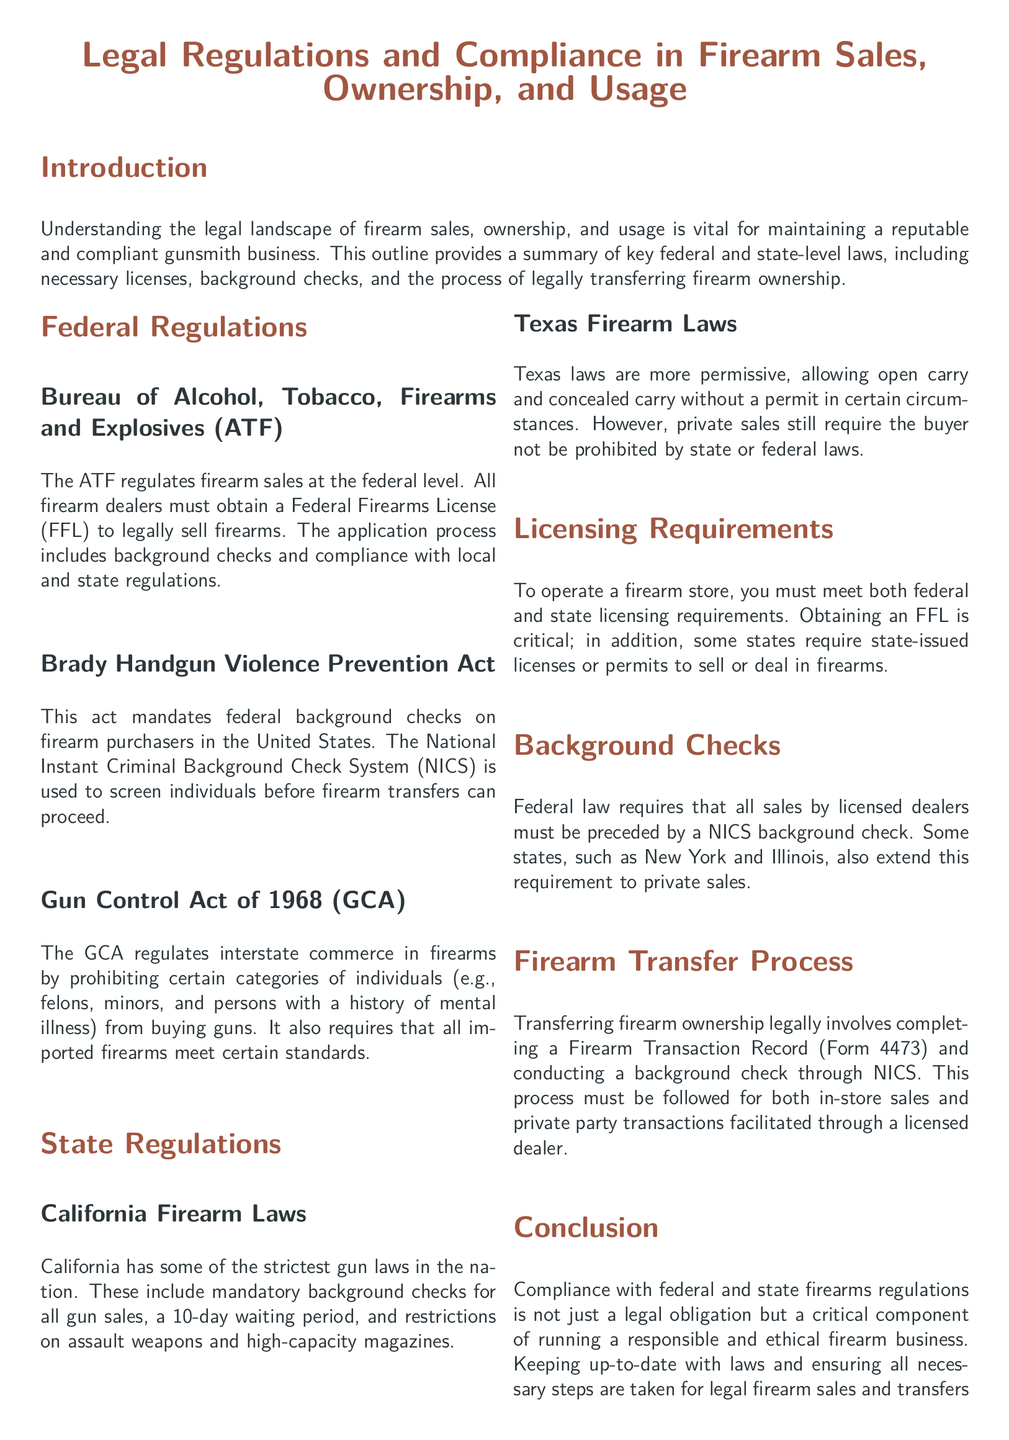What federal agency regulates firearm sales? The document states that the Bureau of Alcohol, Tobacco, Firearms and Explosives (ATF) regulates firearm sales at the federal level.
Answer: ATF What act mandates federal background checks? The Brady Handgun Violence Prevention Act is mentioned as mandating federal background checks on firearm purchasers.
Answer: Brady Handgun Violence Prevention Act What is required to sell firearms at the federal level? The document highlights that all firearm dealers must obtain a Federal Firearms License (FFL) to legally sell firearms.
Answer: Federal Firearms License (FFL) What is the waiting period for firearm sales in California? According to the document, California has a 10-day waiting period for gun sales.
Answer: 10-day waiting period What document must be completed for transferring firearm ownership? The Firearm Transaction Record (Form 4473) must be completed for transferring firearm ownership.
Answer: Form 4473 What is a requirement for background checks during licensed sales? The document specifies that federal law requires that all sales by licensed dealers must be preceded by a NICS background check.
Answer: NICS background check How does Texas firearm law differ from California's? The document indicates Texas laws are more permissive, allowing open carry and concealed carry without a permit in certain circumstances.
Answer: More permissive laws Which category of individuals is prohibited from buying guns under the GCA? The Gun Control Act of 1968 prohibits individuals such as felons, minors, and persons with a history of mental illness from buying guns.
Answer: Felons, minors, persons with mental illness 